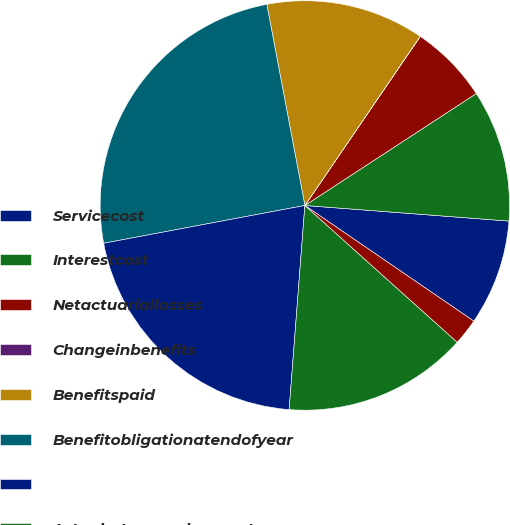<chart> <loc_0><loc_0><loc_500><loc_500><pie_chart><fcel>Servicecost<fcel>Interestcost<fcel>Netactuariallosses<fcel>Changeinbenefits<fcel>Benefitspaid<fcel>Benefitobligationatendofyear<fcel>Unnamed: 6<fcel>Actualreturnonplanassets<fcel>Employercontribution<nl><fcel>8.34%<fcel>10.42%<fcel>6.26%<fcel>0.01%<fcel>12.5%<fcel>24.98%<fcel>20.82%<fcel>14.58%<fcel>2.09%<nl></chart> 